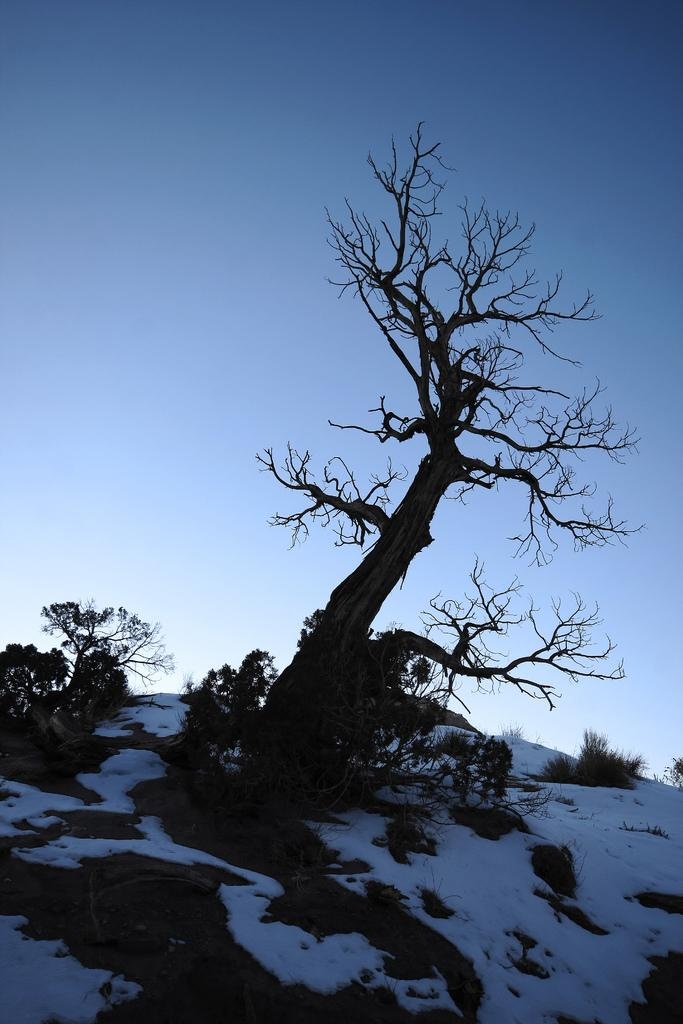What is the main object in the image? There is a tree in the image. What is the condition of the ground around the tree? The ground around the tree is covered with snow. What color is the sky in the image? The sky is blue in color. What can be seen on the left side of the image? There are plants on the left side of the image. What type of curtain is hanging in the middle of the tree? There is no curtain present in the image; it features a tree on snow-covered land with a blue sky and plants on the left side. 